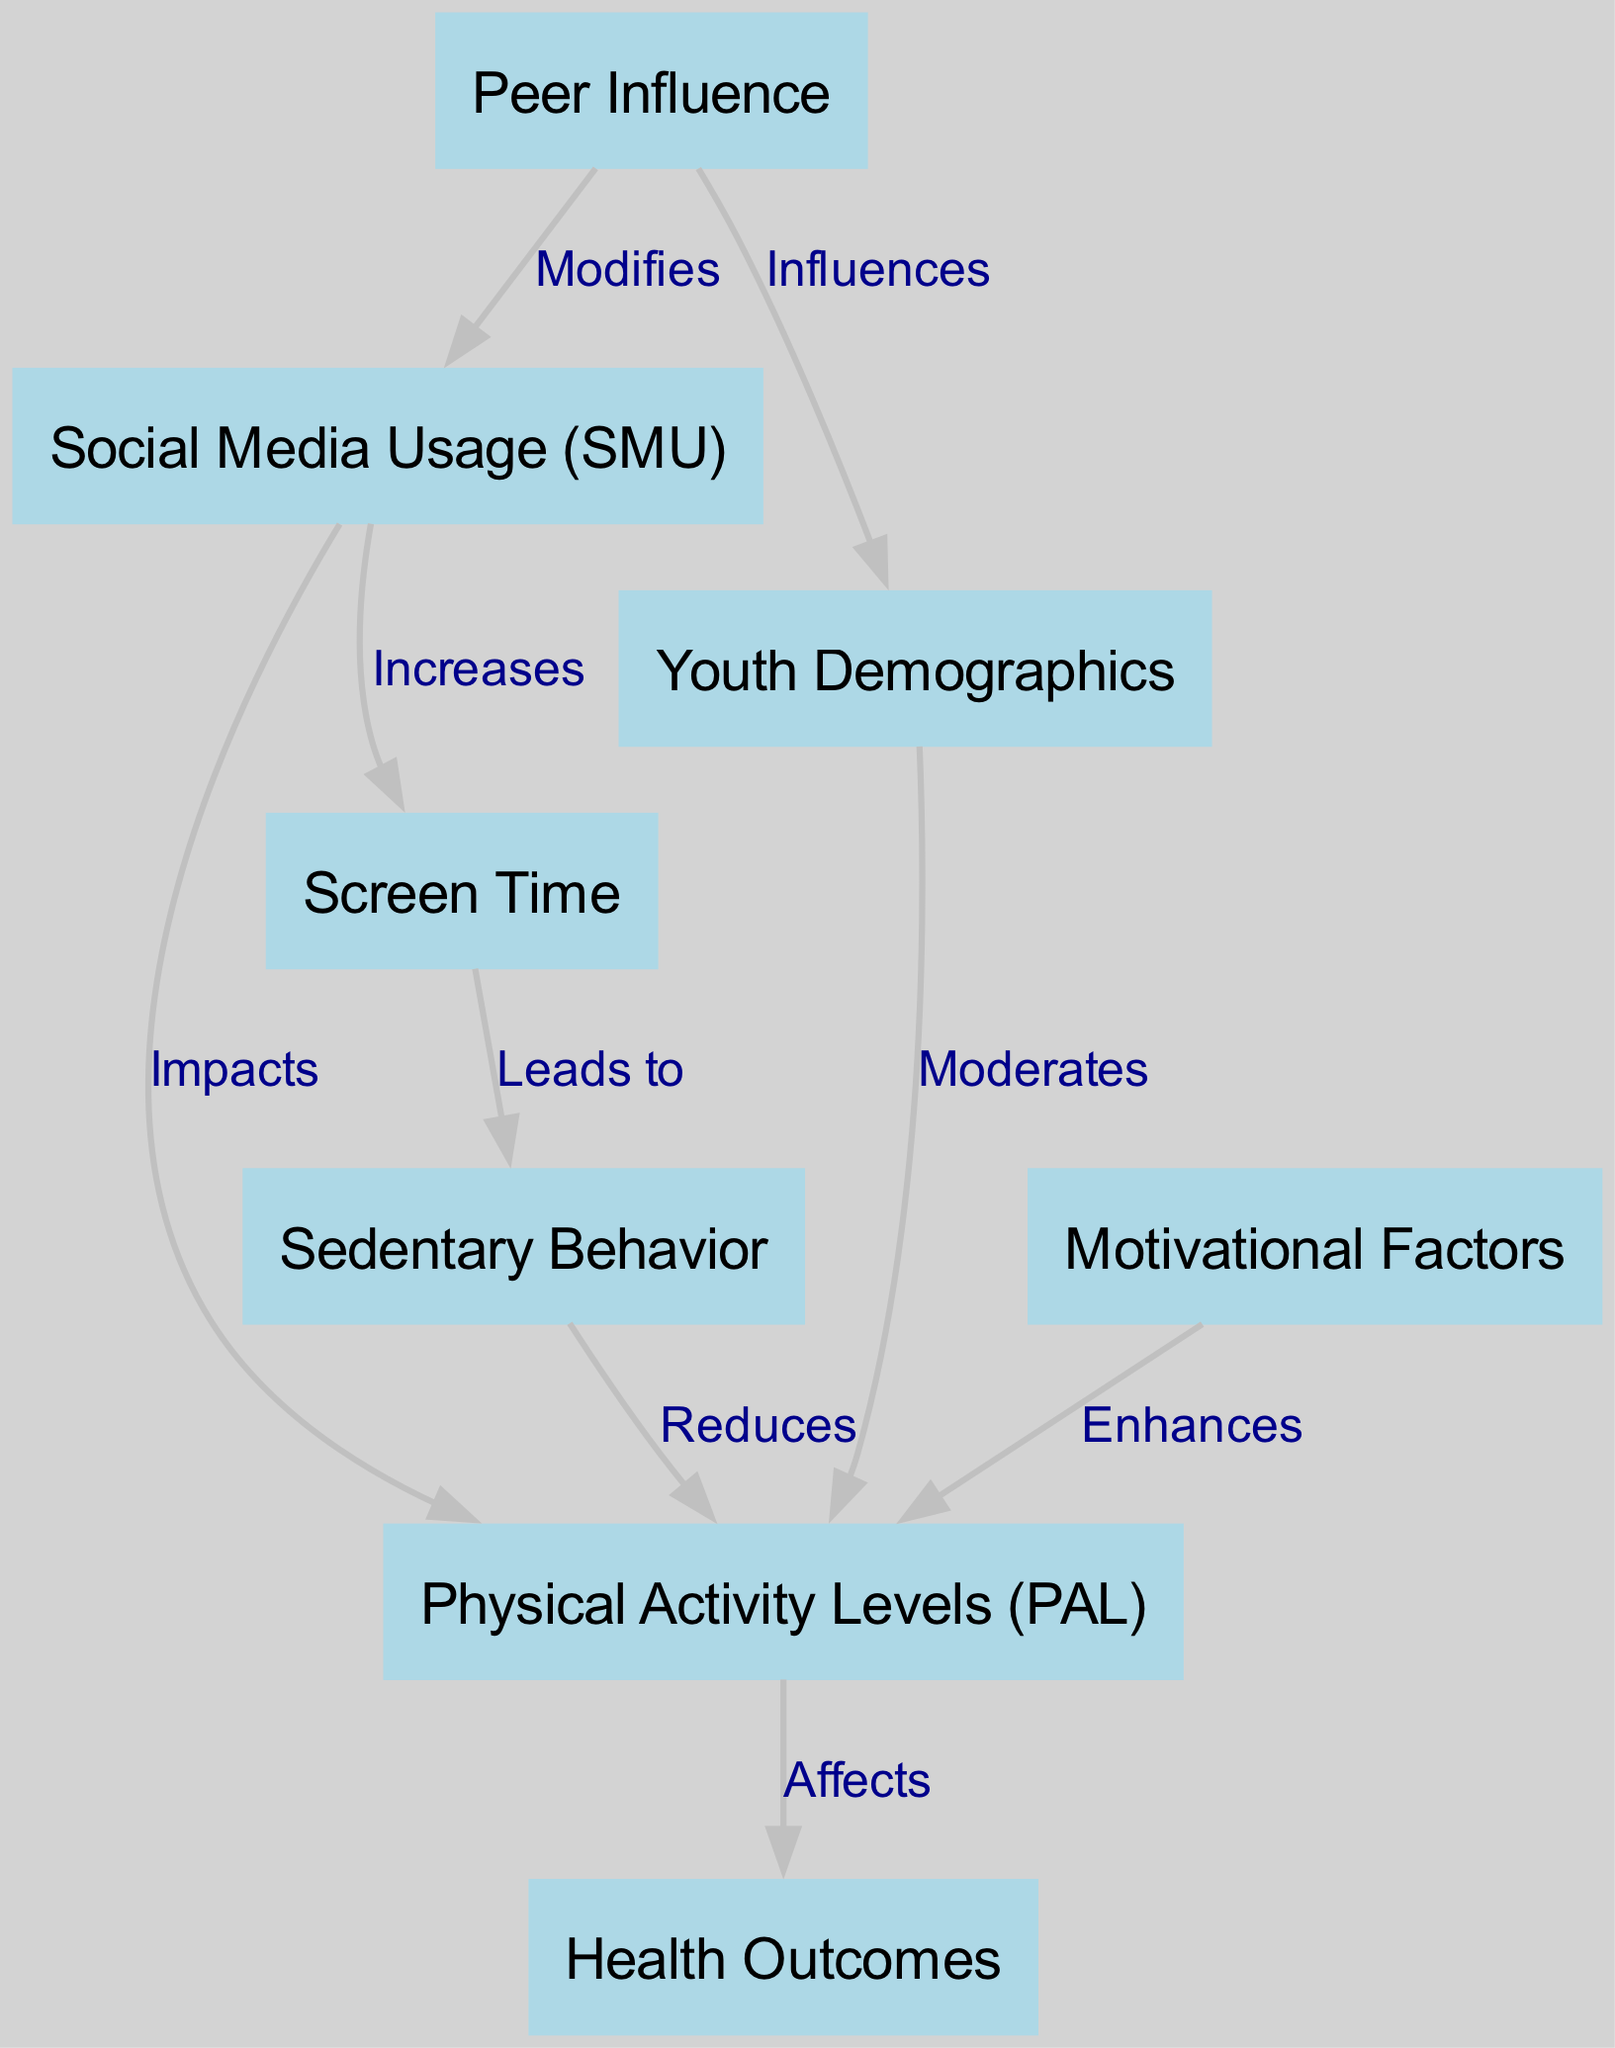What is the relationship between Social Media Usage and Physical Activity Levels? The diagram indicates a directed edge labeled "Impacts" from the node "Social Media Usage (SMU)" to the node "Physical Activity Levels (PAL)", which shows that social media usage has a direct impact on physical activity levels among youth.
Answer: Impacts How many nodes are present in the diagram? The diagram consists of 8 nodes: Social Media Usage, Physical Activity Levels, Youth Demographics, Health Outcomes, Screen Time, Sedentary Behavior, Motivational Factors, and Peer Influence.
Answer: 8 What effect does Screen Time have on Sedentary Behavior? The edge labeled "Leads to" from "Screen Time" to "Sedentary Behavior" signifies that an increase in screen time contributes to more sedentary behavior among youth.
Answer: Leads to Which node moderates the relationship between Youth Demographics and Physical Activity Levels? The edge labeled "Moderates" points from "Youth Demographics" to "Physical Activity Levels", indicating that youth demographics influence how physical activity levels are affected.
Answer: Moderates What is the connection between Sedentary Behavior and Physical Activity Levels? There is an edge labeled "Reduces" that goes from "Sedentary Behavior" to "Physical Activity Levels", meaning that increased sedentary behavior decreases physical activity levels.
Answer: Reduces How does Motivational Factors influence Physical Activity Levels? The arrow labeled "Enhances" from "Motivational Factors" to "Physical Activity Levels" indicates that motivational factors positively enhance physical activity levels.
Answer: Enhances What factors influence Social Media Usage? The diagram shows an edge labeled "Modifies" from "Peer Influence" to "Social Media Usage", which means that peer influence modifies how youth use social media.
Answer: Modifies Which node is affected by Physical Activity Levels directly? The edge labeled "Affects" from "Physical Activity Levels" to "Health Outcomes" clearly shows that health outcomes are directly affected by physical activity levels.
Answer: Affects What type of behavior does increased Screen Time lead to? The edge between "Screen Time" and "Sedentary Behavior" indicates that it leads to a sedentary lifestyle when screen time increases.
Answer: Sedentary Behavior 